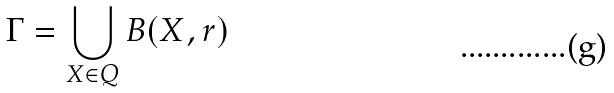<formula> <loc_0><loc_0><loc_500><loc_500>\Gamma = \bigcup _ { X \in Q } B ( X , r )</formula> 